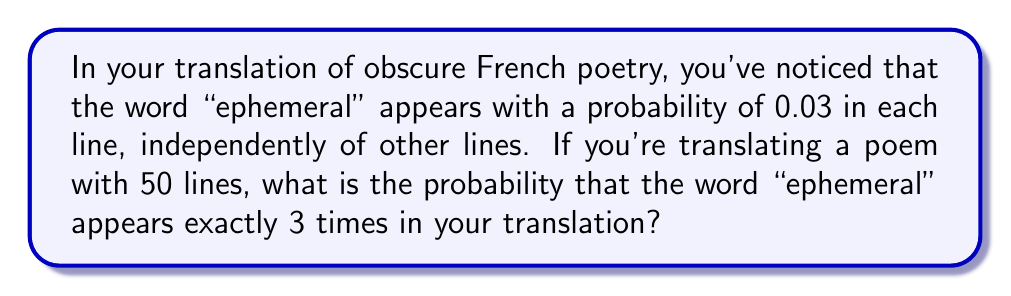Can you answer this question? To solve this problem, we can use the Binomial probability distribution, as we have:
1. A fixed number of independent trials (50 lines)
2. Each trial has two possible outcomes (word appears or doesn't appear)
3. The probability of success (word appearing) is constant for each trial

Let $X$ be the random variable representing the number of times "ephemeral" appears in the 50-line poem.

$X \sim B(n,p)$ where:
$n = 50$ (number of lines)
$p = 0.03$ (probability of "ephemeral" appearing in each line)

We want to find $P(X = 3)$

The probability mass function for a Binomial distribution is:

$$P(X = k) = \binom{n}{k} p^k (1-p)^{n-k}$$

Substituting our values:

$$P(X = 3) = \binom{50}{3} (0.03)^3 (1-0.03)^{50-3}$$

$$= \binom{50}{3} (0.03)^3 (0.97)^{47}$$

$$= 19,600 \times 0.000027 \times 0.2335$$

$$= 0.1240$$

Therefore, the probability of "ephemeral" appearing exactly 3 times in the 50-line poem translation is approximately 0.1240 or 12.40%.
Answer: 0.1240 